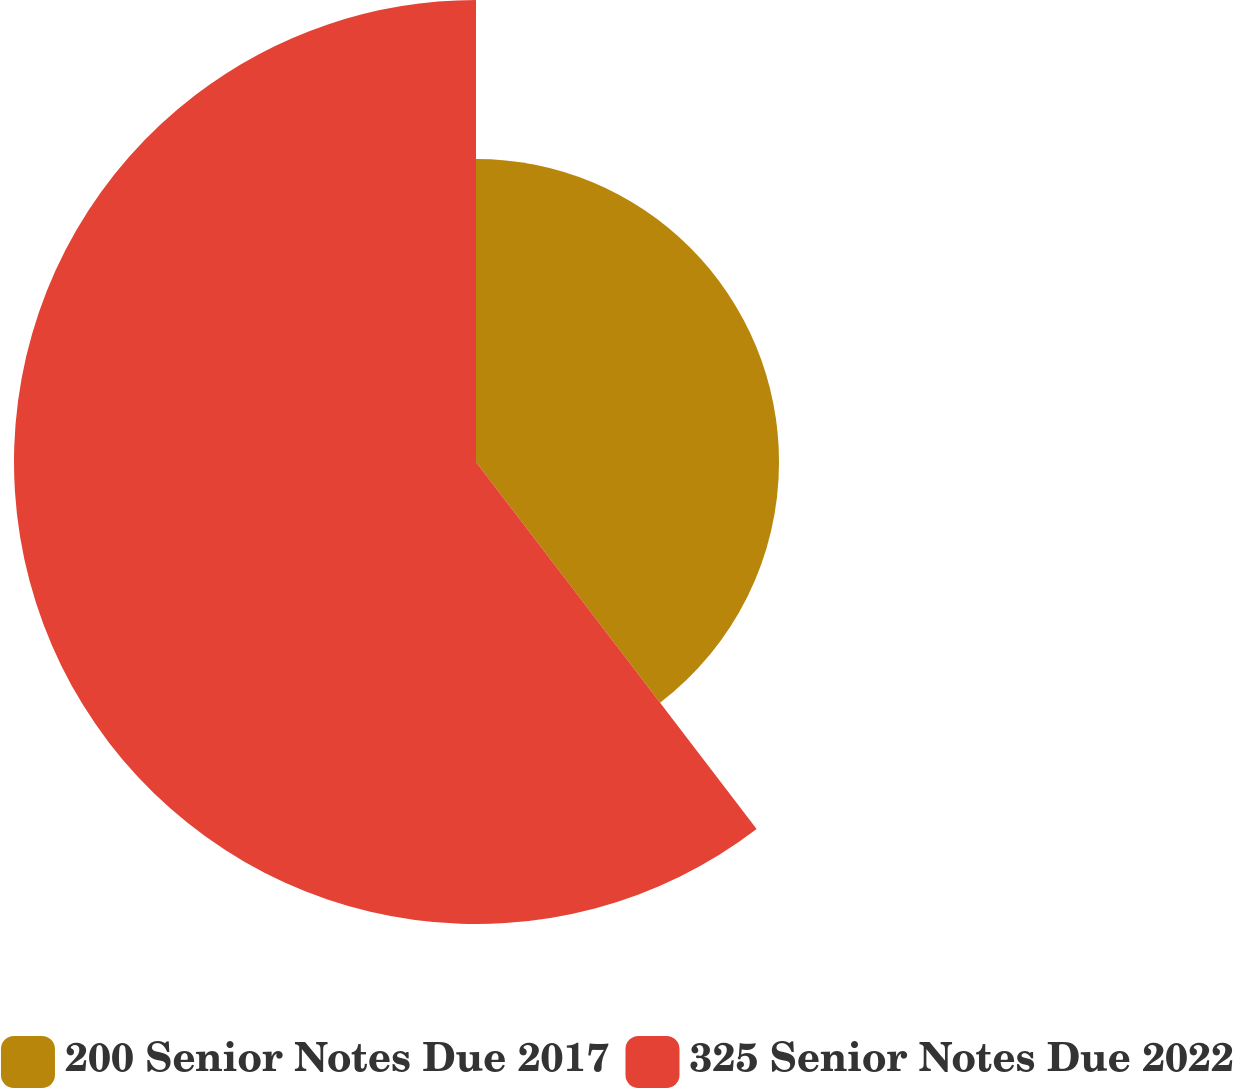<chart> <loc_0><loc_0><loc_500><loc_500><pie_chart><fcel>200 Senior Notes Due 2017<fcel>325 Senior Notes Due 2022<nl><fcel>39.61%<fcel>60.39%<nl></chart> 